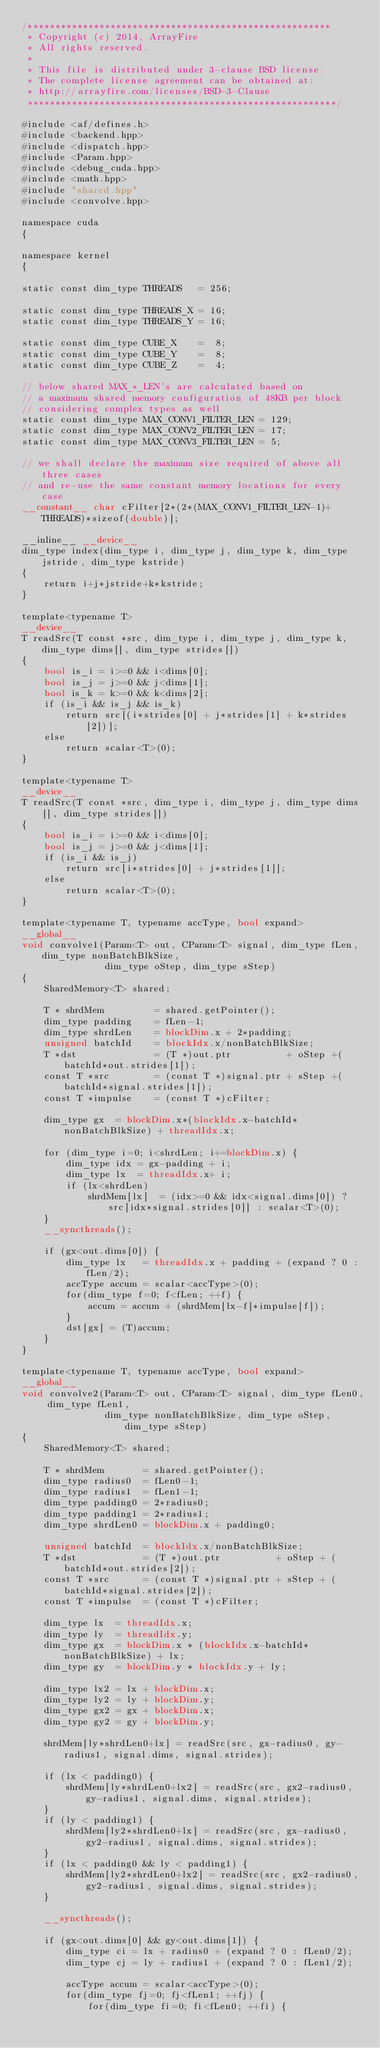Convert code to text. <code><loc_0><loc_0><loc_500><loc_500><_Cuda_>/*******************************************************
 * Copyright (c) 2014, ArrayFire
 * All rights reserved.
 *
 * This file is distributed under 3-clause BSD license.
 * The complete license agreement can be obtained at:
 * http://arrayfire.com/licenses/BSD-3-Clause
 ********************************************************/

#include <af/defines.h>
#include <backend.hpp>
#include <dispatch.hpp>
#include <Param.hpp>
#include <debug_cuda.hpp>
#include <math.hpp>
#include "shared.hpp"
#include <convolve.hpp>

namespace cuda
{

namespace kernel
{

static const dim_type THREADS   = 256;

static const dim_type THREADS_X = 16;
static const dim_type THREADS_Y = 16;

static const dim_type CUBE_X    =  8;
static const dim_type CUBE_Y    =  8;
static const dim_type CUBE_Z    =  4;

// below shared MAX_*_LEN's are calculated based on
// a maximum shared memory configuration of 48KB per block
// considering complex types as well
static const dim_type MAX_CONV1_FILTER_LEN = 129;
static const dim_type MAX_CONV2_FILTER_LEN = 17;
static const dim_type MAX_CONV3_FILTER_LEN = 5;

// we shall declare the maximum size required of above all three cases
// and re-use the same constant memory locations for every case
__constant__ char cFilter[2*(2*(MAX_CONV1_FILTER_LEN-1)+THREADS)*sizeof(double)];

__inline__ __device__
dim_type index(dim_type i, dim_type j, dim_type k, dim_type jstride, dim_type kstride)
{
    return i+j*jstride+k*kstride;
}

template<typename T>
__device__
T readSrc(T const *src, dim_type i, dim_type j, dim_type k, dim_type dims[], dim_type strides[])
{
    bool is_i = i>=0 && i<dims[0];
    bool is_j = j>=0 && j<dims[1];
    bool is_k = k>=0 && k<dims[2];
    if (is_i && is_j && is_k)
        return src[(i*strides[0] + j*strides[1] + k*strides[2])];
    else
        return scalar<T>(0);
}

template<typename T>
__device__
T readSrc(T const *src, dim_type i, dim_type j, dim_type dims[], dim_type strides[])
{
    bool is_i = i>=0 && i<dims[0];
    bool is_j = j>=0 && j<dims[1];
    if (is_i && is_j)
        return src[i*strides[0] + j*strides[1]];
    else
        return scalar<T>(0);
}

template<typename T, typename accType, bool expand>
__global__
void convolve1(Param<T> out, CParam<T> signal, dim_type fLen, dim_type nonBatchBlkSize,
               dim_type oStep, dim_type sStep)
{
    SharedMemory<T> shared;

    T * shrdMem         = shared.getPointer();
    dim_type padding    = fLen-1;
    dim_type shrdLen    = blockDim.x + 2*padding;
    unsigned batchId    = blockIdx.x/nonBatchBlkSize;
    T *dst              = (T *)out.ptr          + oStep +(batchId*out.strides[1]);
    const T *src        = (const T *)signal.ptr + sStep +(batchId*signal.strides[1]);
    const T *impulse    = (const T *)cFilter;

    dim_type gx  = blockDim.x*(blockIdx.x-batchId*nonBatchBlkSize) + threadIdx.x;

    for (dim_type i=0; i<shrdLen; i+=blockDim.x) {
        dim_type idx = gx-padding + i;
        dim_type lx  = threadIdx.x+ i;
        if (lx<shrdLen)
            shrdMem[lx]  = (idx>=0 && idx<signal.dims[0]) ? src[idx*signal.strides[0]] : scalar<T>(0);
    }
    __syncthreads();

    if (gx<out.dims[0]) {
        dim_type lx   = threadIdx.x + padding + (expand ? 0 : fLen/2);
        accType accum = scalar<accType>(0);
        for(dim_type f=0; f<fLen; ++f) {
            accum = accum + (shrdMem[lx-f]*impulse[f]);
        }
        dst[gx] = (T)accum;
    }
}

template<typename T, typename accType, bool expand>
__global__
void convolve2(Param<T> out, CParam<T> signal, dim_type fLen0, dim_type fLen1,
               dim_type nonBatchBlkSize, dim_type oStep, dim_type sStep)
{
    SharedMemory<T> shared;

    T * shrdMem       = shared.getPointer();
    dim_type radius0  = fLen0-1;
    dim_type radius1  = fLen1-1;
    dim_type padding0 = 2*radius0;
    dim_type padding1 = 2*radius1;
    dim_type shrdLen0 = blockDim.x + padding0;

    unsigned batchId  = blockIdx.x/nonBatchBlkSize;
    T *dst            = (T *)out.ptr          + oStep + (batchId*out.strides[2]);
    const T *src      = (const T *)signal.ptr + sStep + (batchId*signal.strides[2]);
    const T *impulse  = (const T *)cFilter;

    dim_type lx  = threadIdx.x;
    dim_type ly  = threadIdx.y;
    dim_type gx  = blockDim.x * (blockIdx.x-batchId*nonBatchBlkSize) + lx;
    dim_type gy  = blockDim.y * blockIdx.y + ly;

    dim_type lx2 = lx + blockDim.x;
    dim_type ly2 = ly + blockDim.y;
    dim_type gx2 = gx + blockDim.x;
    dim_type gy2 = gy + blockDim.y;

    shrdMem[ly*shrdLen0+lx] = readSrc(src, gx-radius0, gy-radius1, signal.dims, signal.strides);

    if (lx < padding0) {
        shrdMem[ly*shrdLen0+lx2] = readSrc(src, gx2-radius0, gy-radius1, signal.dims, signal.strides);
    }
    if (ly < padding1) {
        shrdMem[ly2*shrdLen0+lx] = readSrc(src, gx-radius0, gy2-radius1, signal.dims, signal.strides);
    }
    if (lx < padding0 && ly < padding1) {
        shrdMem[ly2*shrdLen0+lx2] = readSrc(src, gx2-radius0, gy2-radius1, signal.dims, signal.strides);
    }

    __syncthreads();

    if (gx<out.dims[0] && gy<out.dims[1]) {
        dim_type ci = lx + radius0 + (expand ? 0 : fLen0/2);
        dim_type cj = ly + radius1 + (expand ? 0 : fLen1/2);

        accType accum = scalar<accType>(0);
        for(dim_type fj=0; fj<fLen1; ++fj) {
            for(dim_type fi=0; fi<fLen0; ++fi) {</code> 